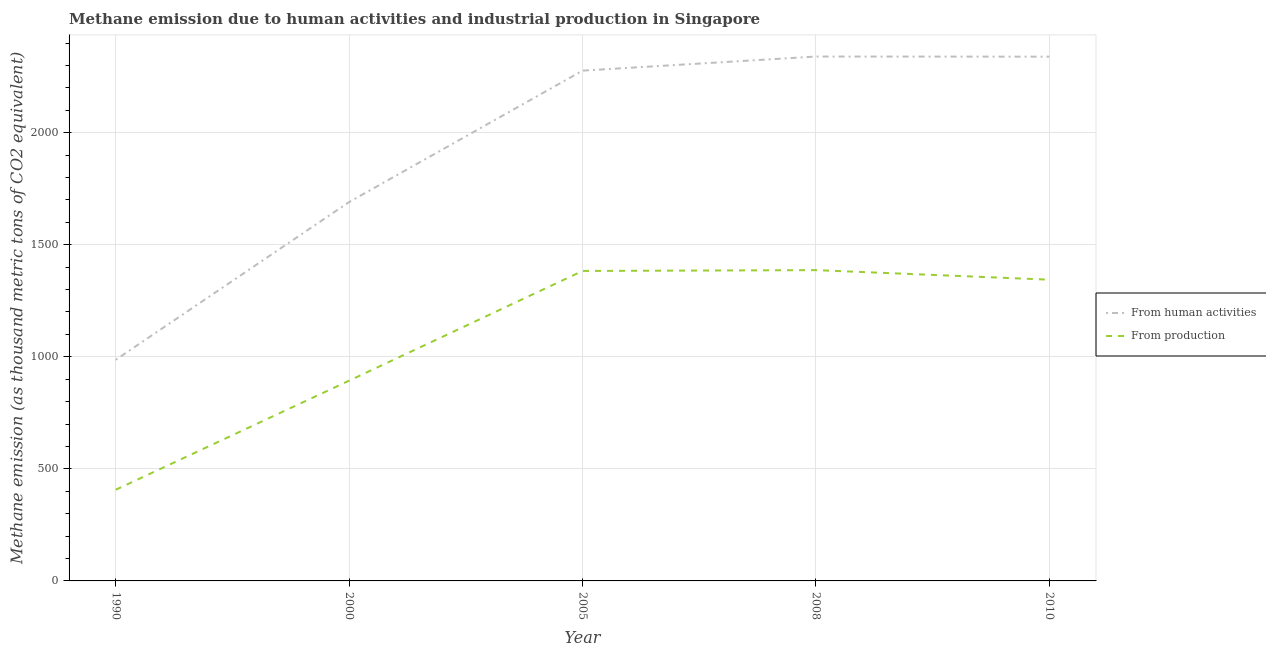How many different coloured lines are there?
Make the answer very short. 2. What is the amount of emissions generated from industries in 1990?
Offer a very short reply. 406.8. Across all years, what is the maximum amount of emissions from human activities?
Make the answer very short. 2339.7. Across all years, what is the minimum amount of emissions from human activities?
Provide a succinct answer. 986.7. In which year was the amount of emissions generated from industries maximum?
Offer a terse response. 2008. In which year was the amount of emissions generated from industries minimum?
Provide a succinct answer. 1990. What is the total amount of emissions generated from industries in the graph?
Your answer should be very brief. 5414.1. What is the difference between the amount of emissions generated from industries in 2008 and that in 2010?
Make the answer very short. 42.6. What is the difference between the amount of emissions generated from industries in 2010 and the amount of emissions from human activities in 2008?
Keep it short and to the point. -995.6. What is the average amount of emissions from human activities per year?
Keep it short and to the point. 1926.58. In the year 2000, what is the difference between the amount of emissions from human activities and amount of emissions generated from industries?
Offer a very short reply. 797.1. In how many years, is the amount of emissions from human activities greater than 700 thousand metric tons?
Your answer should be very brief. 5. What is the ratio of the amount of emissions from human activities in 1990 to that in 2005?
Give a very brief answer. 0.43. Is the amount of emissions generated from industries in 1990 less than that in 2005?
Make the answer very short. Yes. Is the difference between the amount of emissions generated from industries in 2005 and 2008 greater than the difference between the amount of emissions from human activities in 2005 and 2008?
Make the answer very short. Yes. What is the difference between the highest and the second highest amount of emissions generated from industries?
Make the answer very short. 3.7. What is the difference between the highest and the lowest amount of emissions from human activities?
Offer a very short reply. 1353. In how many years, is the amount of emissions from human activities greater than the average amount of emissions from human activities taken over all years?
Provide a succinct answer. 3. Is the sum of the amount of emissions from human activities in 1990 and 2005 greater than the maximum amount of emissions generated from industries across all years?
Your answer should be very brief. Yes. Does the amount of emissions generated from industries monotonically increase over the years?
Your response must be concise. No. Is the amount of emissions generated from industries strictly less than the amount of emissions from human activities over the years?
Ensure brevity in your answer.  Yes. How are the legend labels stacked?
Offer a terse response. Vertical. What is the title of the graph?
Your answer should be compact. Methane emission due to human activities and industrial production in Singapore. What is the label or title of the Y-axis?
Make the answer very short. Methane emission (as thousand metric tons of CO2 equivalent). What is the Methane emission (as thousand metric tons of CO2 equivalent) of From human activities in 1990?
Provide a short and direct response. 986.7. What is the Methane emission (as thousand metric tons of CO2 equivalent) in From production in 1990?
Provide a succinct answer. 406.8. What is the Methane emission (as thousand metric tons of CO2 equivalent) of From human activities in 2000?
Your response must be concise. 1690.6. What is the Methane emission (as thousand metric tons of CO2 equivalent) in From production in 2000?
Offer a terse response. 893.5. What is the Methane emission (as thousand metric tons of CO2 equivalent) of From human activities in 2005?
Your answer should be compact. 2276.8. What is the Methane emission (as thousand metric tons of CO2 equivalent) in From production in 2005?
Make the answer very short. 1383. What is the Methane emission (as thousand metric tons of CO2 equivalent) in From human activities in 2008?
Offer a very short reply. 2339.7. What is the Methane emission (as thousand metric tons of CO2 equivalent) of From production in 2008?
Your answer should be compact. 1386.7. What is the Methane emission (as thousand metric tons of CO2 equivalent) of From human activities in 2010?
Offer a terse response. 2339.1. What is the Methane emission (as thousand metric tons of CO2 equivalent) of From production in 2010?
Provide a short and direct response. 1344.1. Across all years, what is the maximum Methane emission (as thousand metric tons of CO2 equivalent) of From human activities?
Your answer should be compact. 2339.7. Across all years, what is the maximum Methane emission (as thousand metric tons of CO2 equivalent) of From production?
Ensure brevity in your answer.  1386.7. Across all years, what is the minimum Methane emission (as thousand metric tons of CO2 equivalent) in From human activities?
Offer a terse response. 986.7. Across all years, what is the minimum Methane emission (as thousand metric tons of CO2 equivalent) in From production?
Make the answer very short. 406.8. What is the total Methane emission (as thousand metric tons of CO2 equivalent) in From human activities in the graph?
Your answer should be very brief. 9632.9. What is the total Methane emission (as thousand metric tons of CO2 equivalent) in From production in the graph?
Provide a short and direct response. 5414.1. What is the difference between the Methane emission (as thousand metric tons of CO2 equivalent) in From human activities in 1990 and that in 2000?
Make the answer very short. -703.9. What is the difference between the Methane emission (as thousand metric tons of CO2 equivalent) in From production in 1990 and that in 2000?
Give a very brief answer. -486.7. What is the difference between the Methane emission (as thousand metric tons of CO2 equivalent) in From human activities in 1990 and that in 2005?
Provide a short and direct response. -1290.1. What is the difference between the Methane emission (as thousand metric tons of CO2 equivalent) of From production in 1990 and that in 2005?
Provide a succinct answer. -976.2. What is the difference between the Methane emission (as thousand metric tons of CO2 equivalent) in From human activities in 1990 and that in 2008?
Provide a short and direct response. -1353. What is the difference between the Methane emission (as thousand metric tons of CO2 equivalent) of From production in 1990 and that in 2008?
Your answer should be very brief. -979.9. What is the difference between the Methane emission (as thousand metric tons of CO2 equivalent) in From human activities in 1990 and that in 2010?
Offer a very short reply. -1352.4. What is the difference between the Methane emission (as thousand metric tons of CO2 equivalent) in From production in 1990 and that in 2010?
Provide a succinct answer. -937.3. What is the difference between the Methane emission (as thousand metric tons of CO2 equivalent) of From human activities in 2000 and that in 2005?
Give a very brief answer. -586.2. What is the difference between the Methane emission (as thousand metric tons of CO2 equivalent) in From production in 2000 and that in 2005?
Provide a short and direct response. -489.5. What is the difference between the Methane emission (as thousand metric tons of CO2 equivalent) in From human activities in 2000 and that in 2008?
Make the answer very short. -649.1. What is the difference between the Methane emission (as thousand metric tons of CO2 equivalent) in From production in 2000 and that in 2008?
Provide a short and direct response. -493.2. What is the difference between the Methane emission (as thousand metric tons of CO2 equivalent) in From human activities in 2000 and that in 2010?
Provide a short and direct response. -648.5. What is the difference between the Methane emission (as thousand metric tons of CO2 equivalent) of From production in 2000 and that in 2010?
Your answer should be compact. -450.6. What is the difference between the Methane emission (as thousand metric tons of CO2 equivalent) in From human activities in 2005 and that in 2008?
Make the answer very short. -62.9. What is the difference between the Methane emission (as thousand metric tons of CO2 equivalent) in From production in 2005 and that in 2008?
Offer a terse response. -3.7. What is the difference between the Methane emission (as thousand metric tons of CO2 equivalent) of From human activities in 2005 and that in 2010?
Keep it short and to the point. -62.3. What is the difference between the Methane emission (as thousand metric tons of CO2 equivalent) of From production in 2005 and that in 2010?
Keep it short and to the point. 38.9. What is the difference between the Methane emission (as thousand metric tons of CO2 equivalent) in From production in 2008 and that in 2010?
Make the answer very short. 42.6. What is the difference between the Methane emission (as thousand metric tons of CO2 equivalent) of From human activities in 1990 and the Methane emission (as thousand metric tons of CO2 equivalent) of From production in 2000?
Your answer should be compact. 93.2. What is the difference between the Methane emission (as thousand metric tons of CO2 equivalent) in From human activities in 1990 and the Methane emission (as thousand metric tons of CO2 equivalent) in From production in 2005?
Your response must be concise. -396.3. What is the difference between the Methane emission (as thousand metric tons of CO2 equivalent) in From human activities in 1990 and the Methane emission (as thousand metric tons of CO2 equivalent) in From production in 2008?
Make the answer very short. -400. What is the difference between the Methane emission (as thousand metric tons of CO2 equivalent) in From human activities in 1990 and the Methane emission (as thousand metric tons of CO2 equivalent) in From production in 2010?
Your answer should be compact. -357.4. What is the difference between the Methane emission (as thousand metric tons of CO2 equivalent) of From human activities in 2000 and the Methane emission (as thousand metric tons of CO2 equivalent) of From production in 2005?
Offer a very short reply. 307.6. What is the difference between the Methane emission (as thousand metric tons of CO2 equivalent) of From human activities in 2000 and the Methane emission (as thousand metric tons of CO2 equivalent) of From production in 2008?
Ensure brevity in your answer.  303.9. What is the difference between the Methane emission (as thousand metric tons of CO2 equivalent) of From human activities in 2000 and the Methane emission (as thousand metric tons of CO2 equivalent) of From production in 2010?
Provide a succinct answer. 346.5. What is the difference between the Methane emission (as thousand metric tons of CO2 equivalent) in From human activities in 2005 and the Methane emission (as thousand metric tons of CO2 equivalent) in From production in 2008?
Ensure brevity in your answer.  890.1. What is the difference between the Methane emission (as thousand metric tons of CO2 equivalent) of From human activities in 2005 and the Methane emission (as thousand metric tons of CO2 equivalent) of From production in 2010?
Ensure brevity in your answer.  932.7. What is the difference between the Methane emission (as thousand metric tons of CO2 equivalent) in From human activities in 2008 and the Methane emission (as thousand metric tons of CO2 equivalent) in From production in 2010?
Give a very brief answer. 995.6. What is the average Methane emission (as thousand metric tons of CO2 equivalent) of From human activities per year?
Your response must be concise. 1926.58. What is the average Methane emission (as thousand metric tons of CO2 equivalent) of From production per year?
Offer a terse response. 1082.82. In the year 1990, what is the difference between the Methane emission (as thousand metric tons of CO2 equivalent) of From human activities and Methane emission (as thousand metric tons of CO2 equivalent) of From production?
Offer a very short reply. 579.9. In the year 2000, what is the difference between the Methane emission (as thousand metric tons of CO2 equivalent) in From human activities and Methane emission (as thousand metric tons of CO2 equivalent) in From production?
Offer a very short reply. 797.1. In the year 2005, what is the difference between the Methane emission (as thousand metric tons of CO2 equivalent) in From human activities and Methane emission (as thousand metric tons of CO2 equivalent) in From production?
Your answer should be compact. 893.8. In the year 2008, what is the difference between the Methane emission (as thousand metric tons of CO2 equivalent) of From human activities and Methane emission (as thousand metric tons of CO2 equivalent) of From production?
Your response must be concise. 953. In the year 2010, what is the difference between the Methane emission (as thousand metric tons of CO2 equivalent) in From human activities and Methane emission (as thousand metric tons of CO2 equivalent) in From production?
Give a very brief answer. 995. What is the ratio of the Methane emission (as thousand metric tons of CO2 equivalent) of From human activities in 1990 to that in 2000?
Make the answer very short. 0.58. What is the ratio of the Methane emission (as thousand metric tons of CO2 equivalent) of From production in 1990 to that in 2000?
Offer a very short reply. 0.46. What is the ratio of the Methane emission (as thousand metric tons of CO2 equivalent) of From human activities in 1990 to that in 2005?
Offer a terse response. 0.43. What is the ratio of the Methane emission (as thousand metric tons of CO2 equivalent) in From production in 1990 to that in 2005?
Give a very brief answer. 0.29. What is the ratio of the Methane emission (as thousand metric tons of CO2 equivalent) in From human activities in 1990 to that in 2008?
Your response must be concise. 0.42. What is the ratio of the Methane emission (as thousand metric tons of CO2 equivalent) in From production in 1990 to that in 2008?
Offer a very short reply. 0.29. What is the ratio of the Methane emission (as thousand metric tons of CO2 equivalent) in From human activities in 1990 to that in 2010?
Ensure brevity in your answer.  0.42. What is the ratio of the Methane emission (as thousand metric tons of CO2 equivalent) of From production in 1990 to that in 2010?
Your answer should be compact. 0.3. What is the ratio of the Methane emission (as thousand metric tons of CO2 equivalent) of From human activities in 2000 to that in 2005?
Provide a short and direct response. 0.74. What is the ratio of the Methane emission (as thousand metric tons of CO2 equivalent) in From production in 2000 to that in 2005?
Your answer should be very brief. 0.65. What is the ratio of the Methane emission (as thousand metric tons of CO2 equivalent) in From human activities in 2000 to that in 2008?
Keep it short and to the point. 0.72. What is the ratio of the Methane emission (as thousand metric tons of CO2 equivalent) in From production in 2000 to that in 2008?
Your answer should be very brief. 0.64. What is the ratio of the Methane emission (as thousand metric tons of CO2 equivalent) of From human activities in 2000 to that in 2010?
Offer a terse response. 0.72. What is the ratio of the Methane emission (as thousand metric tons of CO2 equivalent) of From production in 2000 to that in 2010?
Your answer should be very brief. 0.66. What is the ratio of the Methane emission (as thousand metric tons of CO2 equivalent) in From human activities in 2005 to that in 2008?
Your answer should be very brief. 0.97. What is the ratio of the Methane emission (as thousand metric tons of CO2 equivalent) in From production in 2005 to that in 2008?
Offer a very short reply. 1. What is the ratio of the Methane emission (as thousand metric tons of CO2 equivalent) of From human activities in 2005 to that in 2010?
Your answer should be very brief. 0.97. What is the ratio of the Methane emission (as thousand metric tons of CO2 equivalent) of From production in 2005 to that in 2010?
Ensure brevity in your answer.  1.03. What is the ratio of the Methane emission (as thousand metric tons of CO2 equivalent) of From human activities in 2008 to that in 2010?
Your response must be concise. 1. What is the ratio of the Methane emission (as thousand metric tons of CO2 equivalent) in From production in 2008 to that in 2010?
Provide a succinct answer. 1.03. What is the difference between the highest and the lowest Methane emission (as thousand metric tons of CO2 equivalent) in From human activities?
Keep it short and to the point. 1353. What is the difference between the highest and the lowest Methane emission (as thousand metric tons of CO2 equivalent) in From production?
Ensure brevity in your answer.  979.9. 